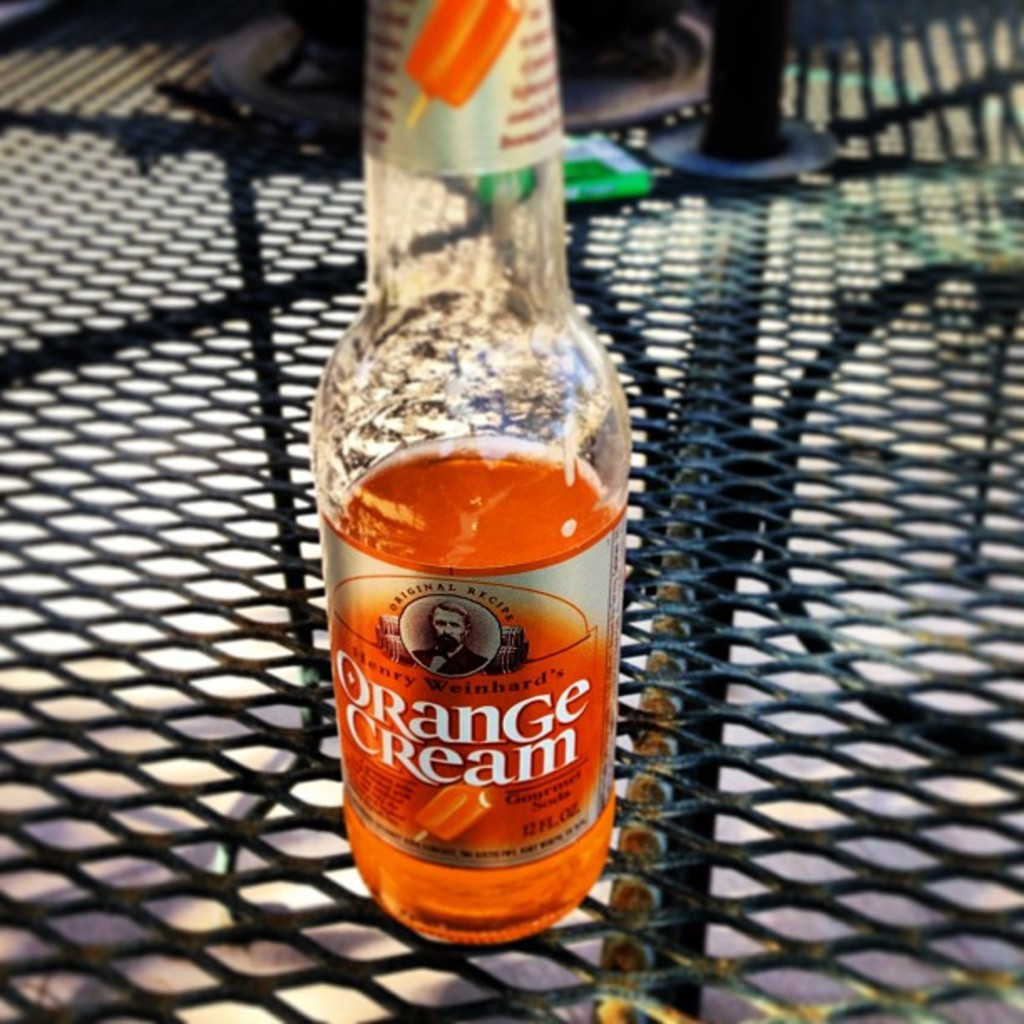Provide a one-sentence caption for the provided image.
Reference OCR token: PRanGe, eishard, eam A glass bottle half full of Orange Cream soda from Henry Weinhard. 